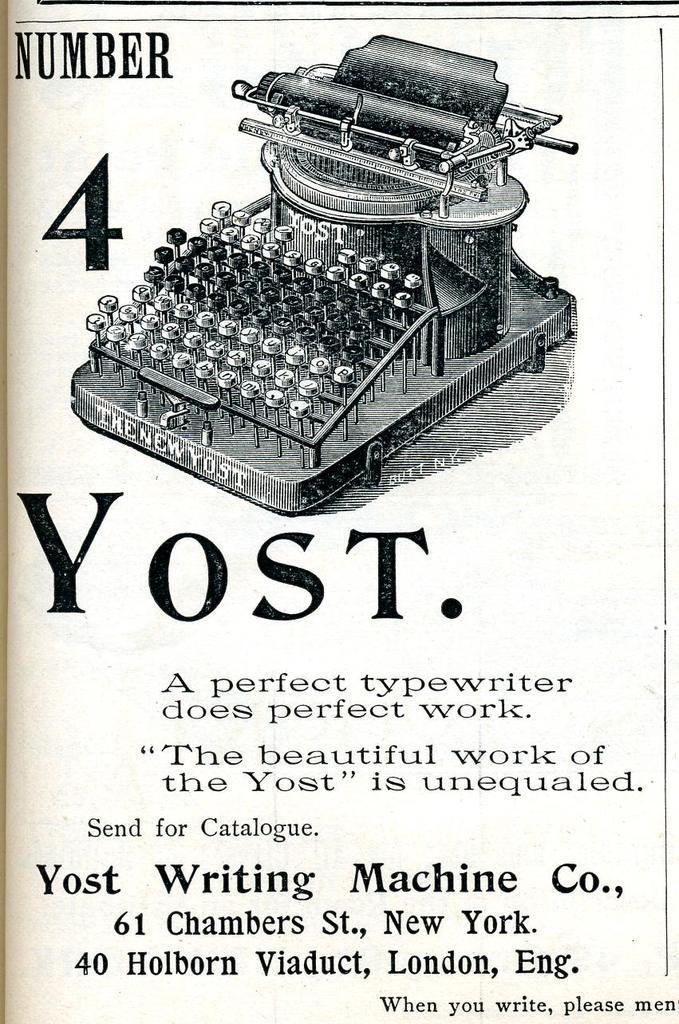Describe this image in one or two sentences. This is a poster having a painting of a typing machine, black colored text and numbers. And the background of this poster is white in color. 